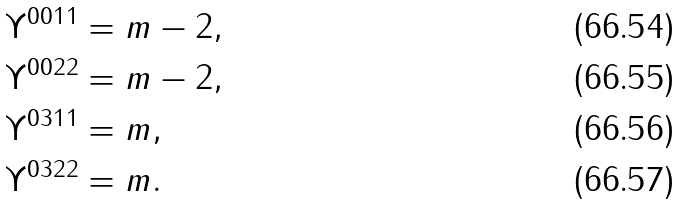Convert formula to latex. <formula><loc_0><loc_0><loc_500><loc_500>\Upsilon ^ { 0 0 1 1 } & = m - 2 , \\ \Upsilon ^ { 0 0 2 2 } & = m - 2 , \\ \Upsilon ^ { 0 3 1 1 } & = m , \\ \Upsilon ^ { 0 3 2 2 } & = m .</formula> 